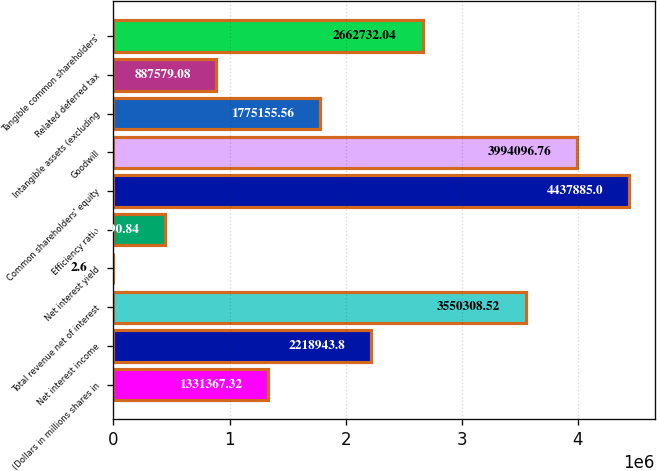Convert chart. <chart><loc_0><loc_0><loc_500><loc_500><bar_chart><fcel>(Dollars in millions shares in<fcel>Net interest income<fcel>Total revenue net of interest<fcel>Net interest yield<fcel>Efficiency ratio<fcel>Common shareholders' equity<fcel>Goodwill<fcel>Intangible assets (excluding<fcel>Related deferred tax<fcel>Tangible common shareholders'<nl><fcel>1.33137e+06<fcel>2.21894e+06<fcel>3.55031e+06<fcel>2.6<fcel>443791<fcel>4.43788e+06<fcel>3.9941e+06<fcel>1.77516e+06<fcel>887579<fcel>2.66273e+06<nl></chart> 